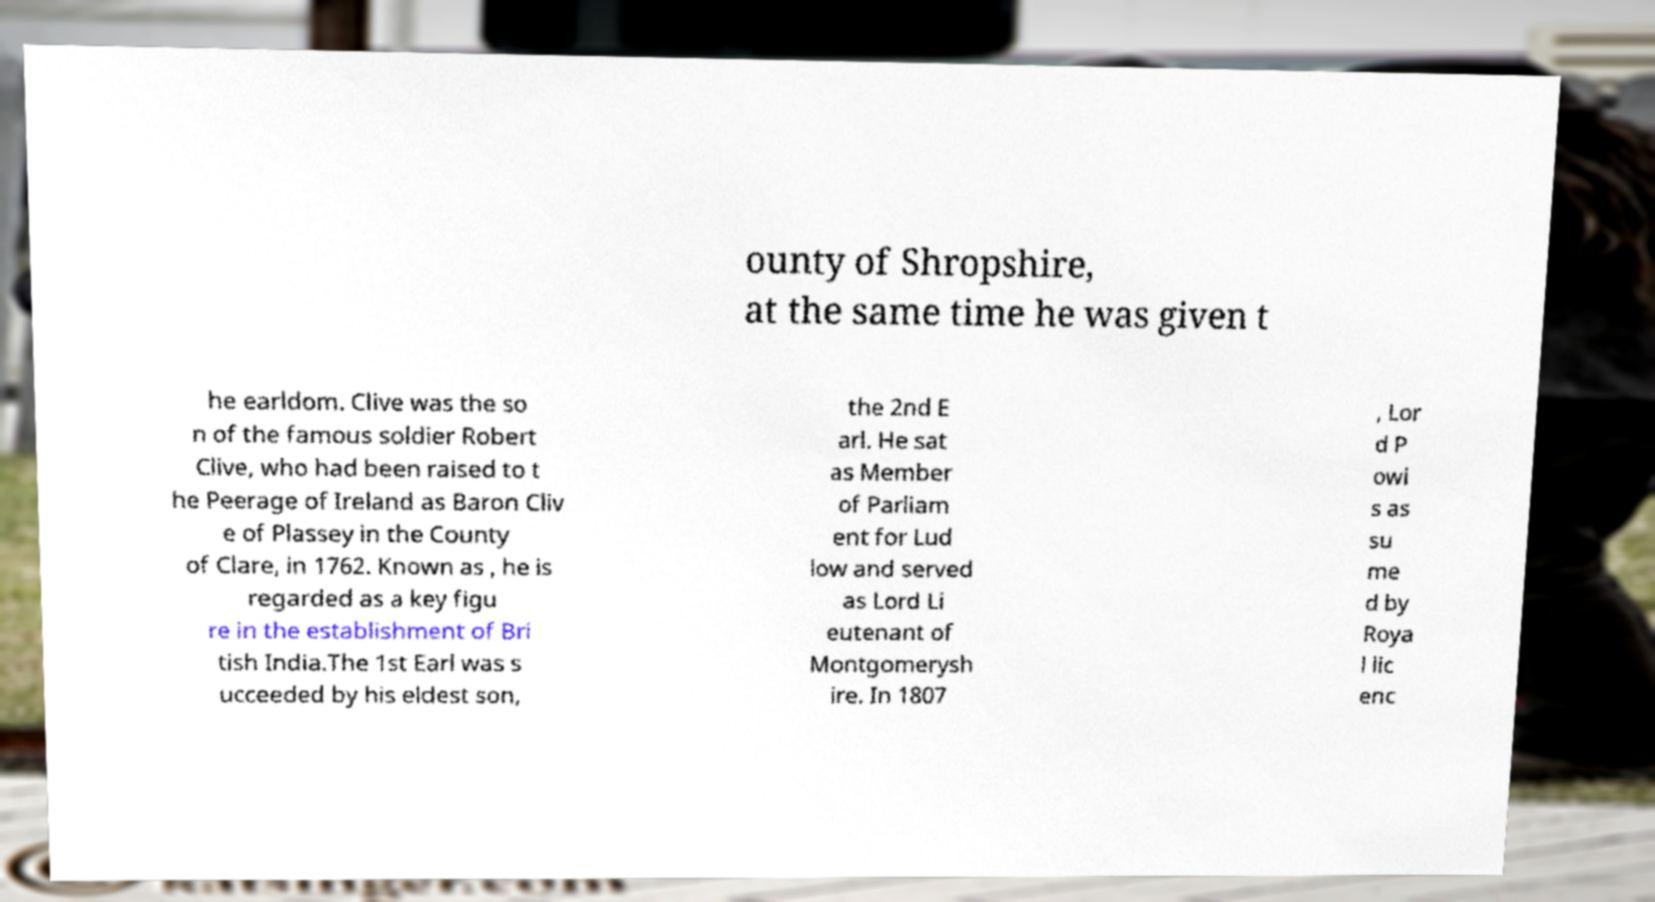There's text embedded in this image that I need extracted. Can you transcribe it verbatim? ounty of Shropshire, at the same time he was given t he earldom. Clive was the so n of the famous soldier Robert Clive, who had been raised to t he Peerage of Ireland as Baron Cliv e of Plassey in the County of Clare, in 1762. Known as , he is regarded as a key figu re in the establishment of Bri tish India.The 1st Earl was s ucceeded by his eldest son, the 2nd E arl. He sat as Member of Parliam ent for Lud low and served as Lord Li eutenant of Montgomerysh ire. In 1807 , Lor d P owi s as su me d by Roya l lic enc 